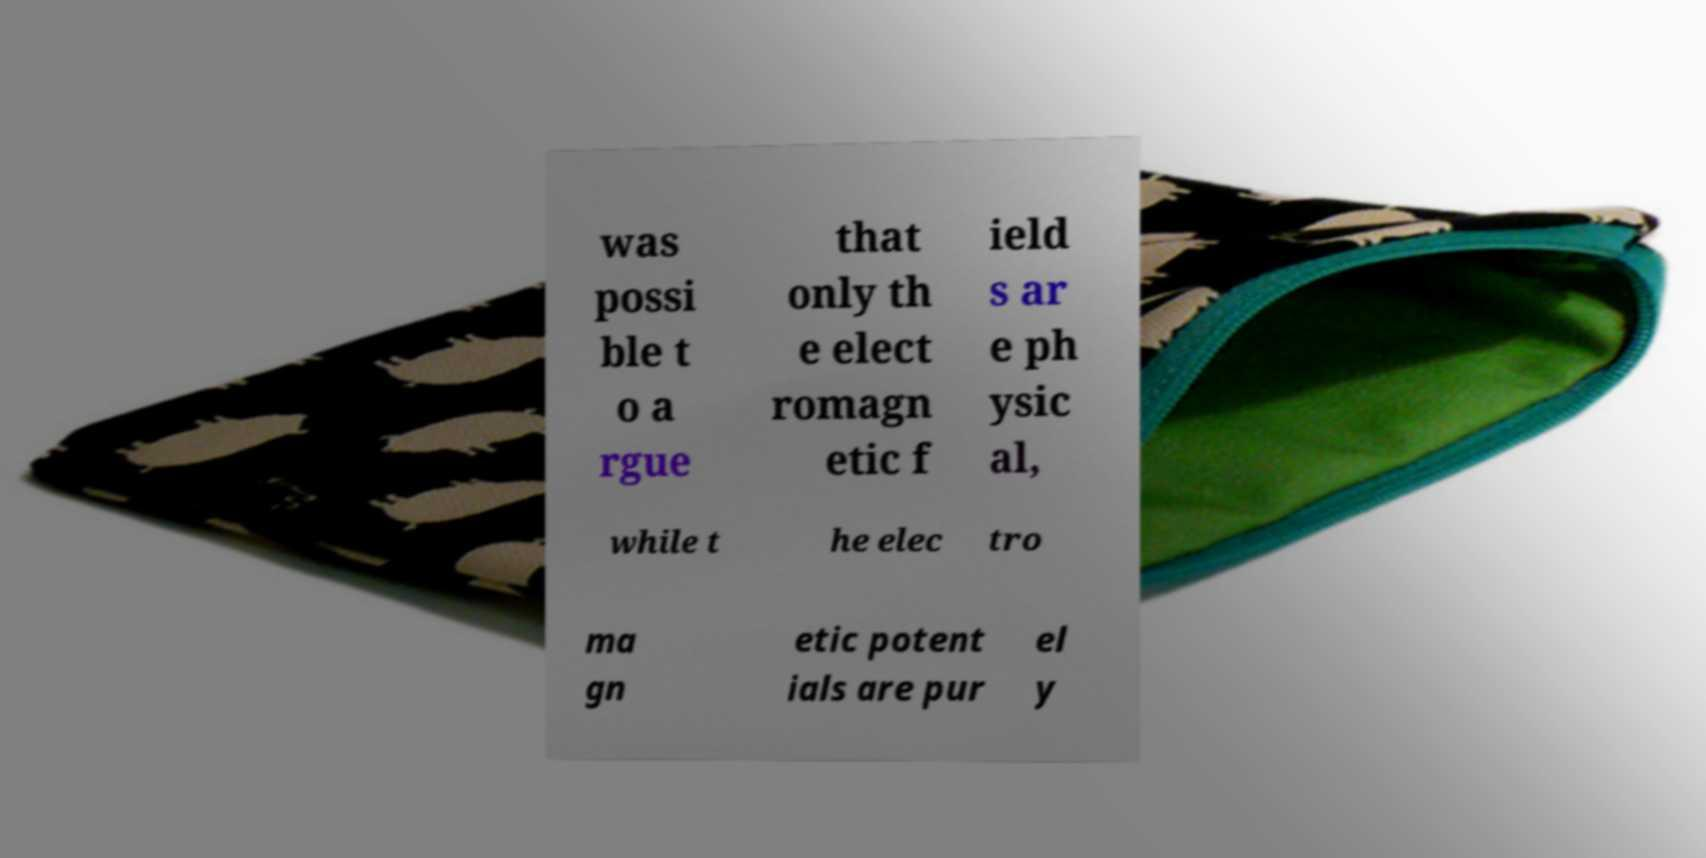Can you accurately transcribe the text from the provided image for me? was possi ble t o a rgue that only th e elect romagn etic f ield s ar e ph ysic al, while t he elec tro ma gn etic potent ials are pur el y 